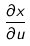Convert formula to latex. <formula><loc_0><loc_0><loc_500><loc_500>\frac { \partial x } { \partial u }</formula> 